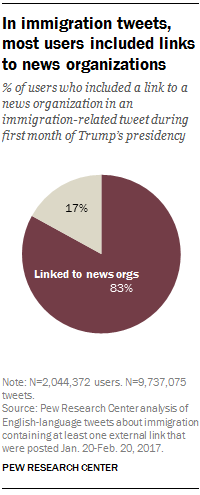Identify some key points in this picture. The value of the red pie is 0.83. The grey pie has a value of 0.17. 